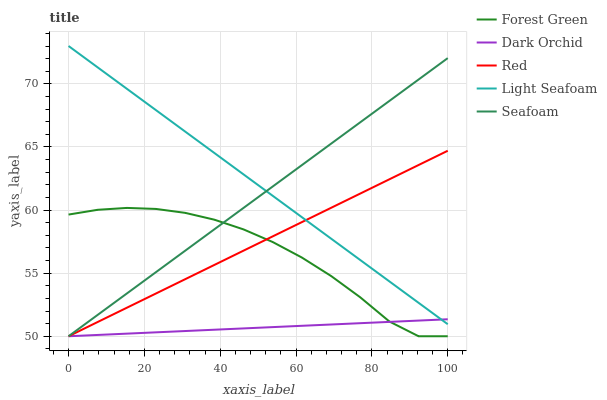Does Dark Orchid have the minimum area under the curve?
Answer yes or no. Yes. Does Light Seafoam have the maximum area under the curve?
Answer yes or no. Yes. Does Red have the minimum area under the curve?
Answer yes or no. No. Does Red have the maximum area under the curve?
Answer yes or no. No. Is Red the smoothest?
Answer yes or no. Yes. Is Forest Green the roughest?
Answer yes or no. Yes. Is Light Seafoam the smoothest?
Answer yes or no. No. Is Light Seafoam the roughest?
Answer yes or no. No. Does Light Seafoam have the lowest value?
Answer yes or no. No. Does Red have the highest value?
Answer yes or no. No. Is Forest Green less than Light Seafoam?
Answer yes or no. Yes. Is Light Seafoam greater than Forest Green?
Answer yes or no. Yes. Does Forest Green intersect Light Seafoam?
Answer yes or no. No. 